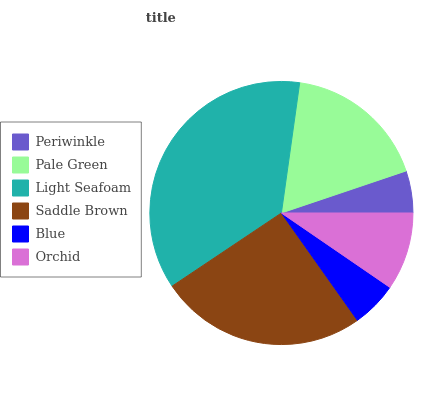Is Periwinkle the minimum?
Answer yes or no. Yes. Is Light Seafoam the maximum?
Answer yes or no. Yes. Is Pale Green the minimum?
Answer yes or no. No. Is Pale Green the maximum?
Answer yes or no. No. Is Pale Green greater than Periwinkle?
Answer yes or no. Yes. Is Periwinkle less than Pale Green?
Answer yes or no. Yes. Is Periwinkle greater than Pale Green?
Answer yes or no. No. Is Pale Green less than Periwinkle?
Answer yes or no. No. Is Pale Green the high median?
Answer yes or no. Yes. Is Orchid the low median?
Answer yes or no. Yes. Is Orchid the high median?
Answer yes or no. No. Is Blue the low median?
Answer yes or no. No. 